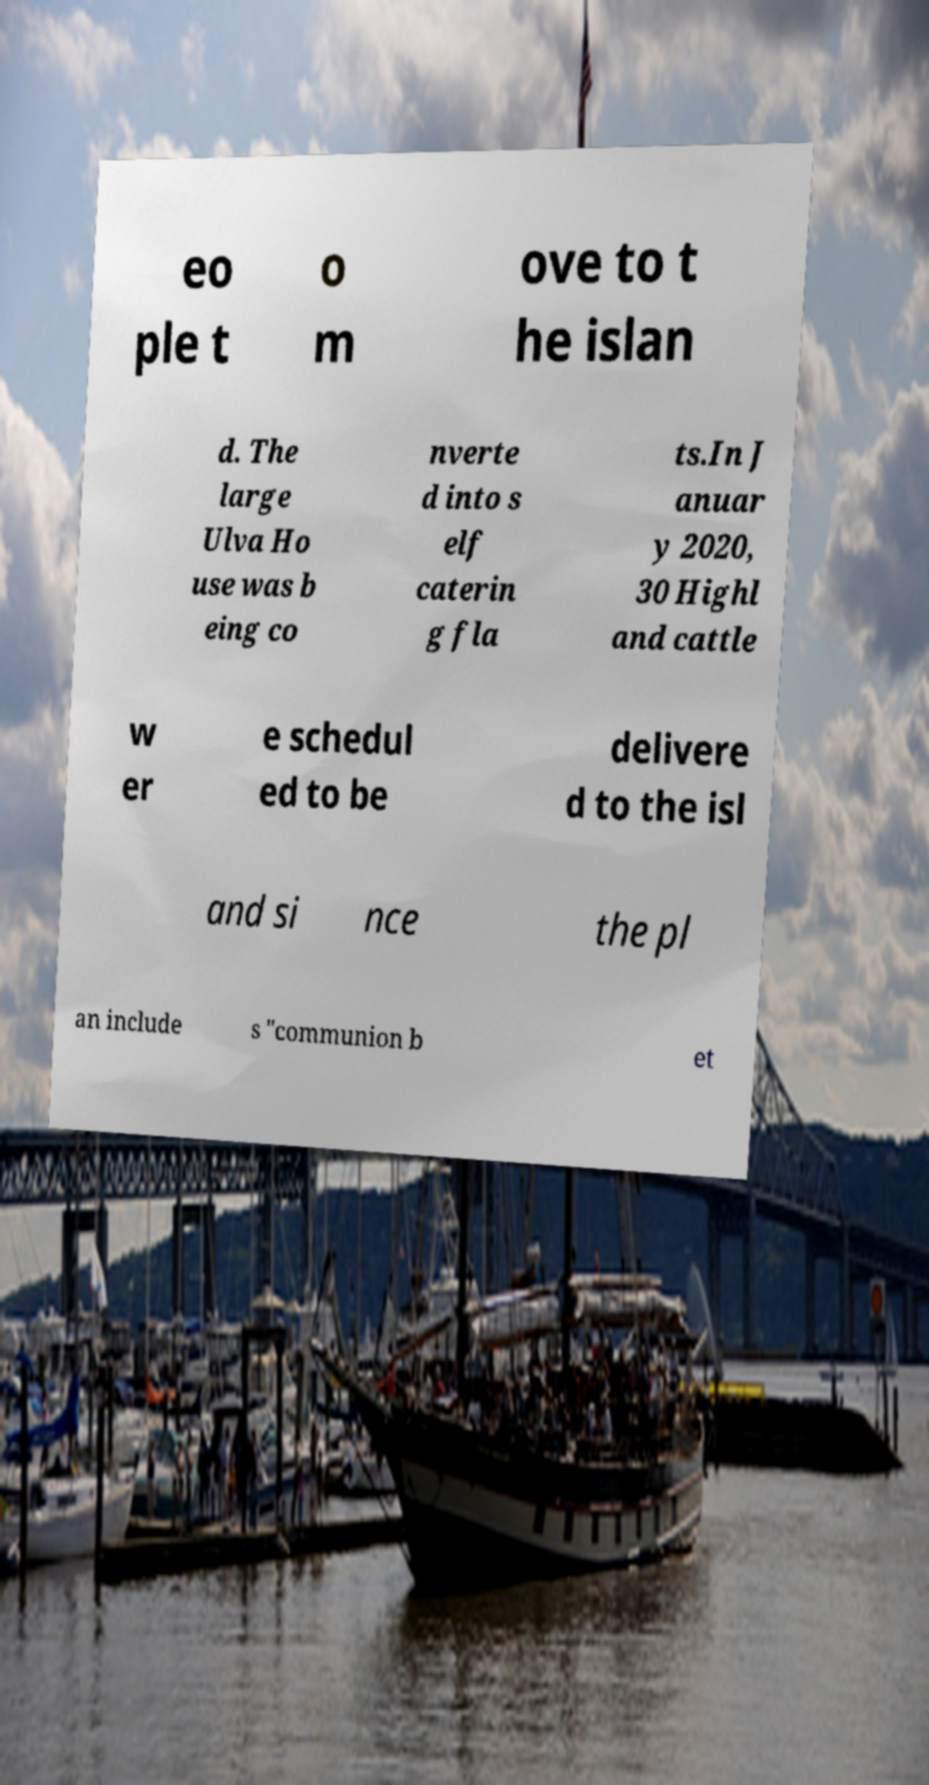Can you accurately transcribe the text from the provided image for me? eo ple t o m ove to t he islan d. The large Ulva Ho use was b eing co nverte d into s elf caterin g fla ts.In J anuar y 2020, 30 Highl and cattle w er e schedul ed to be delivere d to the isl and si nce the pl an include s "communion b et 